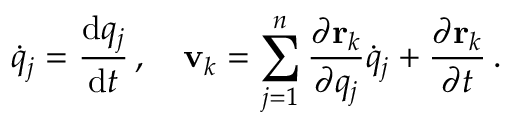<formula> <loc_0><loc_0><loc_500><loc_500>{ \dot { q } } _ { j } = { \frac { d q _ { j } } { d t } } \, , \quad v _ { k } = \sum _ { j = 1 } ^ { n } { \frac { \partial r _ { k } } { \partial q _ { j } } } { \dot { q } } _ { j } + { \frac { \partial r _ { k } } { \partial t } } \, .</formula> 